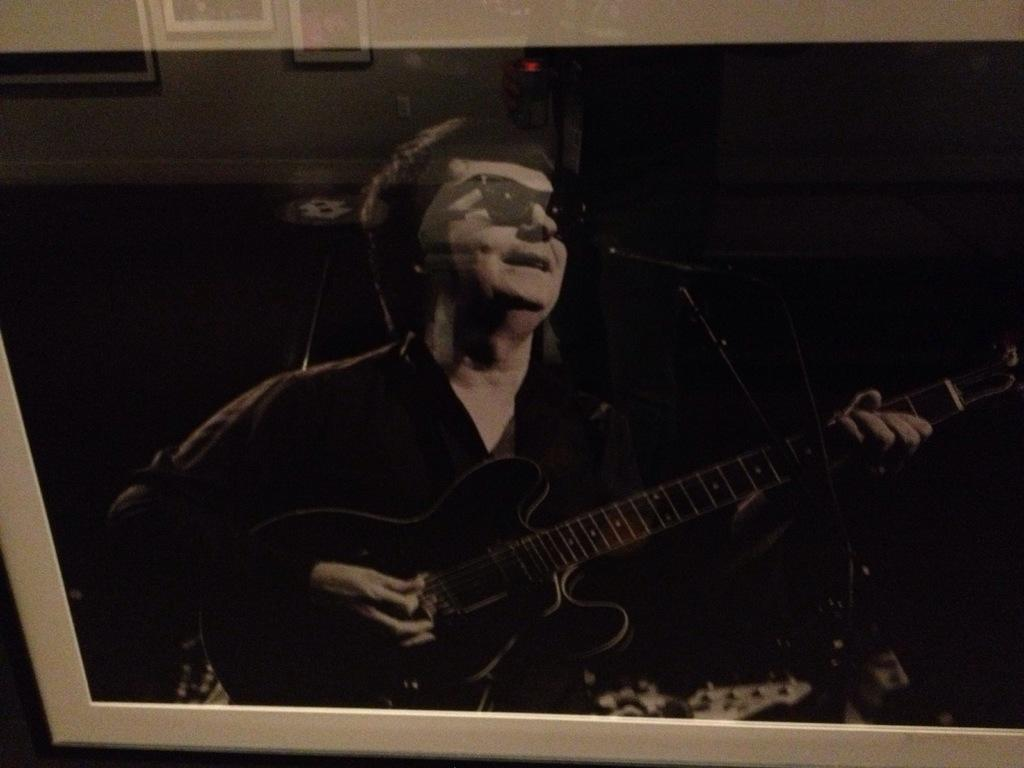What is the person in the image doing? The person is holding a guitar in the image. What is the person's facial expression? The person is smiling in the image. What can be seen on the wall in the image? There are photo frames attached to the wall in the image. How does the person stretch their arms while playing the guitar in the image? The person is not stretching their arms in the image; they are simply holding the guitar. 